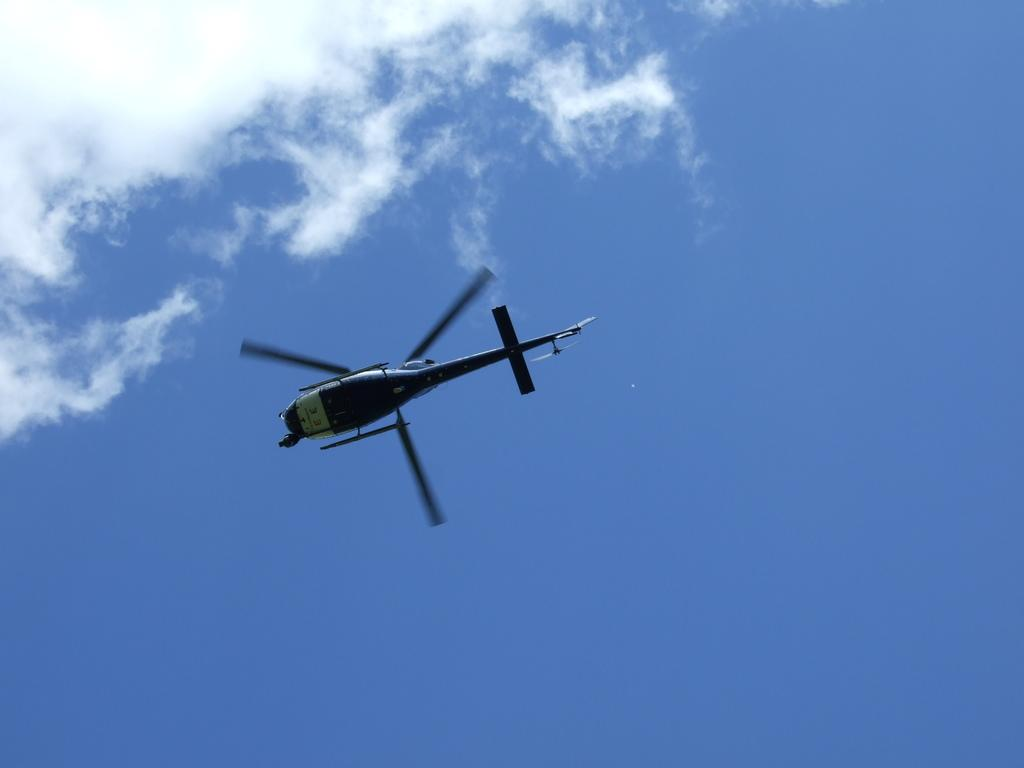What is the main subject of the image? The main subject of the image is a helicopter. What is the color of the sky in the image? The sky in the image is blue. Can you see any fear, trousers, or rabbits in the image? No, there is no fear, trousers, or rabbits present in the image. 